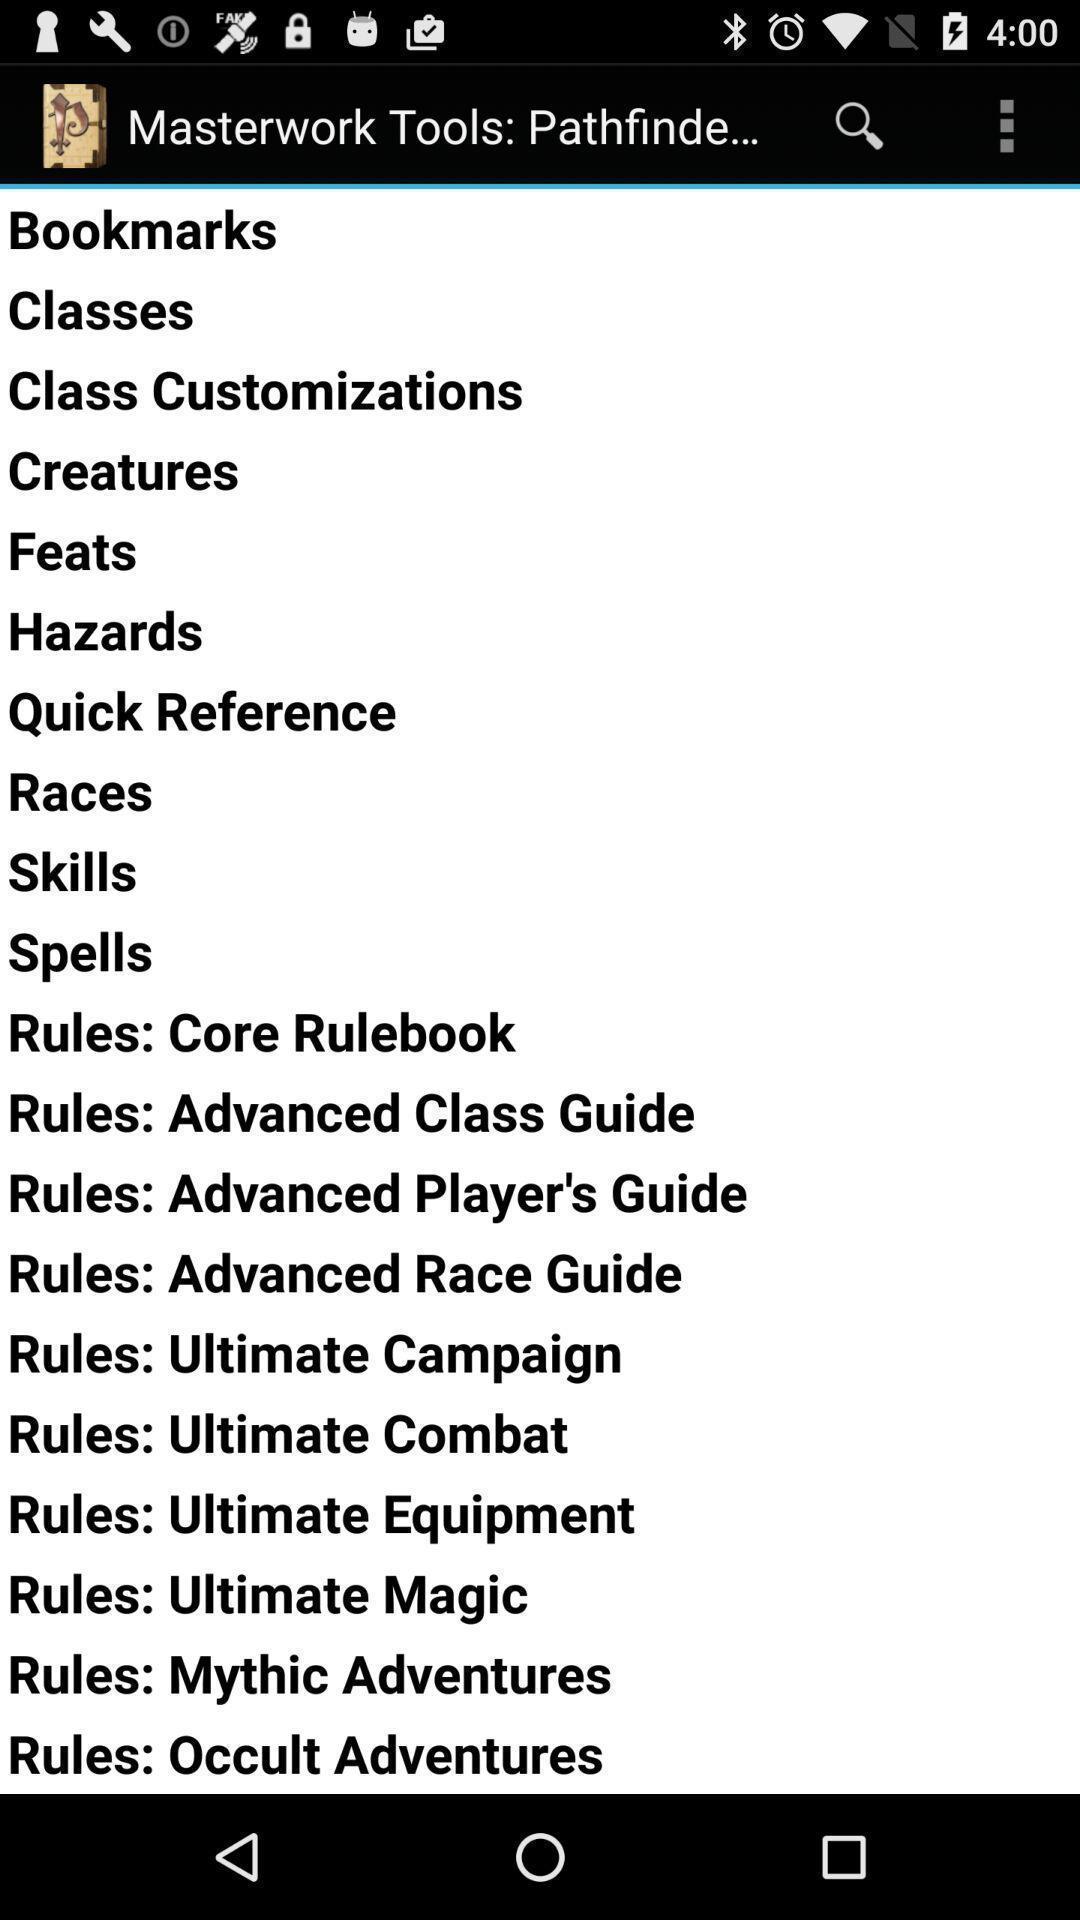Summarize the main components in this picture. Various list page displayed. 